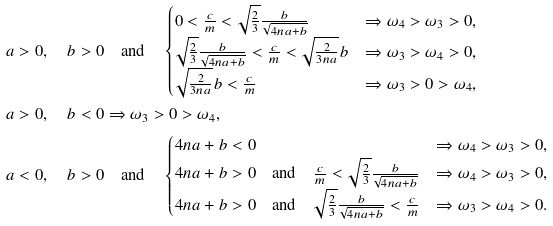Convert formula to latex. <formula><loc_0><loc_0><loc_500><loc_500>& a > 0 , \quad b > 0 \quad \text {and} \quad \begin{cases} 0 < \frac { c } { m } < \sqrt { \frac { 2 } { 3 } } \frac { b } { \sqrt { 4 n a + b } } & \Rightarrow \omega _ { 4 } > \omega _ { 3 } > 0 , \\ \sqrt { \frac { 2 } { 3 } } \frac { b } { \sqrt { 4 n a + b } } < \frac { c } { m } < \sqrt { \frac { 2 } { 3 n a } } b & \Rightarrow \omega _ { 3 } > \omega _ { 4 } > 0 , \\ \sqrt { \frac { 2 } { 3 n a } } b < \frac { c } { m } & \Rightarrow \omega _ { 3 } > 0 > \omega _ { 4 } , \end{cases} \\ & a > 0 , \quad b < 0 \Rightarrow \omega _ { 3 } > 0 > \omega _ { 4 } , \\ & a < 0 , \quad b > 0 \quad \text {and} \quad \begin{cases} 4 n a + b < 0 & \Rightarrow \omega _ { 4 } > \omega _ { 3 } > 0 , \\ 4 n a + b > 0 \quad \text {and} \quad \frac { c } { m } < \sqrt { \frac { 2 } { 3 } } \frac { b } { \sqrt { 4 n a + b } } & \Rightarrow \omega _ { 4 } > \omega _ { 3 } > 0 , \\ 4 n a + b > 0 \quad \text {and} \quad \sqrt { \frac { 2 } { 3 } } \frac { b } { \sqrt { 4 n a + b } } < \frac { c } { m } & \Rightarrow \omega _ { 3 } > \omega _ { 4 } > 0 . \end{cases}</formula> 